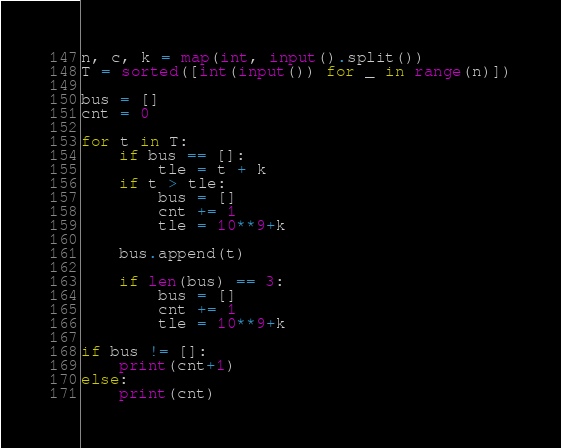Convert code to text. <code><loc_0><loc_0><loc_500><loc_500><_Python_>n, c, k = map(int, input().split())
T = sorted([int(input()) for _ in range(n)])

bus = []
cnt = 0

for t in T:
    if bus == []:
        tle = t + k
    if t > tle:
        bus = []
        cnt += 1
        tle = 10**9+k

    bus.append(t)

    if len(bus) == 3:
        bus = []
        cnt += 1
        tle = 10**9+k

if bus != []:
    print(cnt+1)
else:
    print(cnt)</code> 